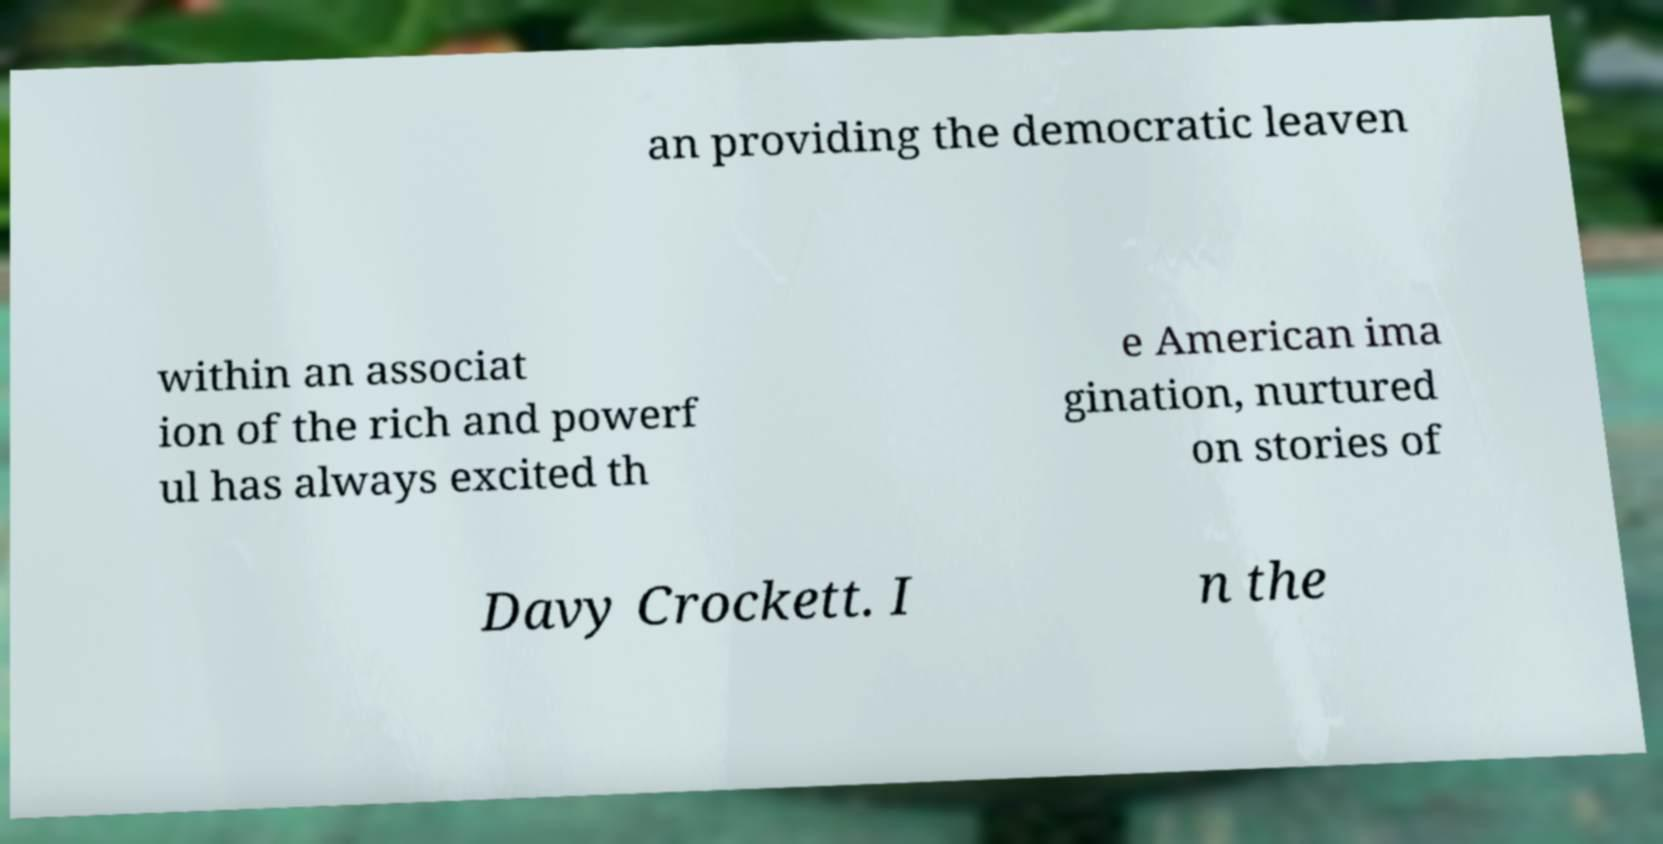Could you extract and type out the text from this image? an providing the democratic leaven within an associat ion of the rich and powerf ul has always excited th e American ima gination, nurtured on stories of Davy Crockett. I n the 